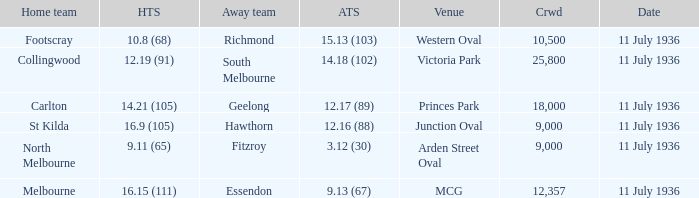What Away team got a team score of 12.16 (88)? Hawthorn. 